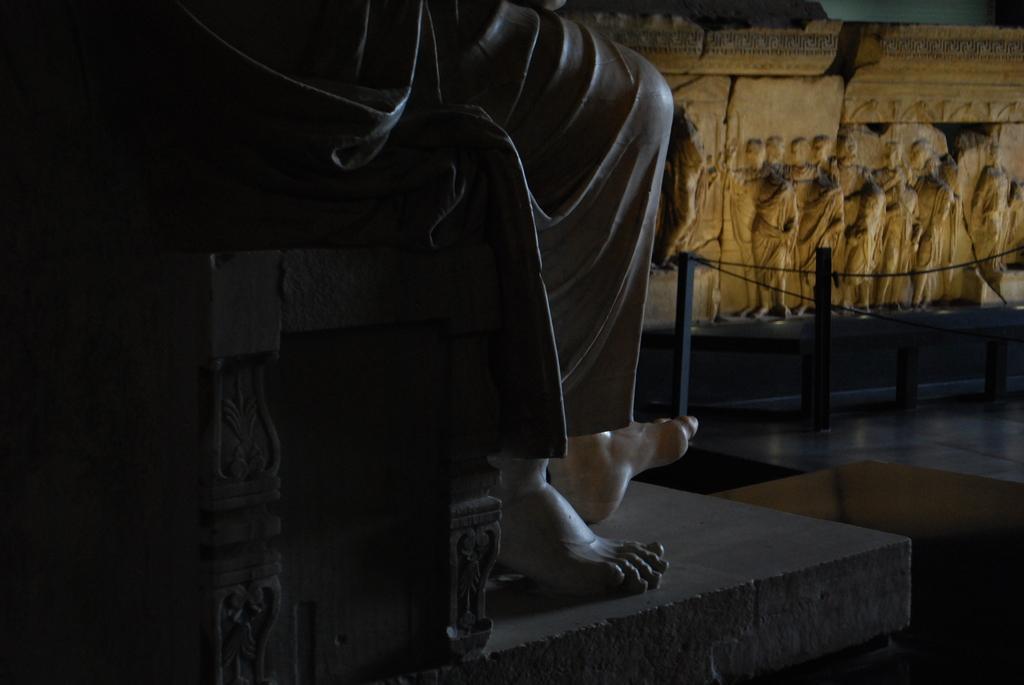Please provide a concise description of this image. This image consists of a statue. There is some wall architecture on the right side. Only the legs of that statue are visible. 